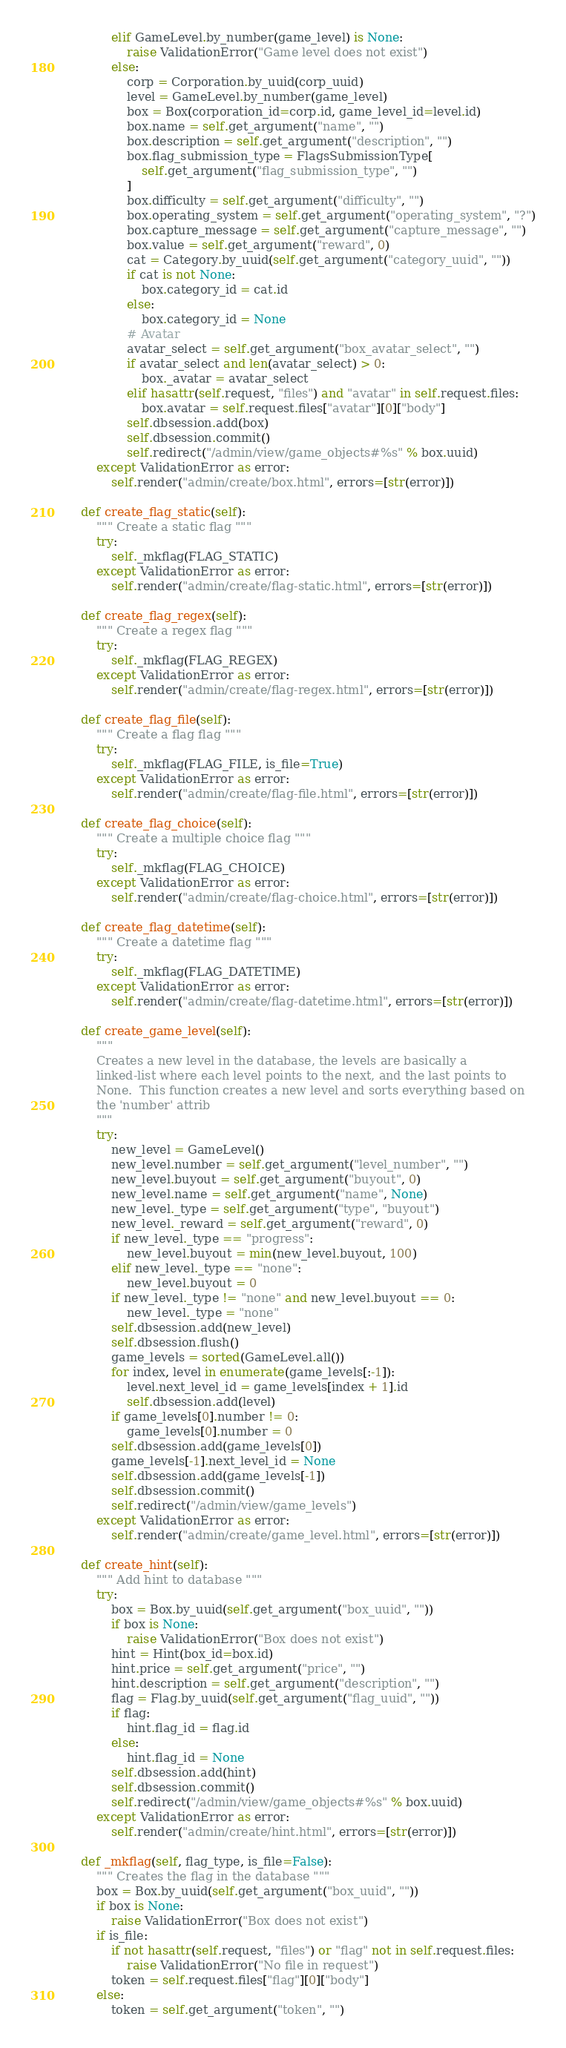Convert code to text. <code><loc_0><loc_0><loc_500><loc_500><_Python_>            elif GameLevel.by_number(game_level) is None:
                raise ValidationError("Game level does not exist")
            else:
                corp = Corporation.by_uuid(corp_uuid)
                level = GameLevel.by_number(game_level)
                box = Box(corporation_id=corp.id, game_level_id=level.id)
                box.name = self.get_argument("name", "")
                box.description = self.get_argument("description", "")
                box.flag_submission_type = FlagsSubmissionType[
                    self.get_argument("flag_submission_type", "")
                ]
                box.difficulty = self.get_argument("difficulty", "")
                box.operating_system = self.get_argument("operating_system", "?")
                box.capture_message = self.get_argument("capture_message", "")
                box.value = self.get_argument("reward", 0)
                cat = Category.by_uuid(self.get_argument("category_uuid", ""))
                if cat is not None:
                    box.category_id = cat.id
                else:
                    box.category_id = None
                # Avatar
                avatar_select = self.get_argument("box_avatar_select", "")
                if avatar_select and len(avatar_select) > 0:
                    box._avatar = avatar_select
                elif hasattr(self.request, "files") and "avatar" in self.request.files:
                    box.avatar = self.request.files["avatar"][0]["body"]
                self.dbsession.add(box)
                self.dbsession.commit()
                self.redirect("/admin/view/game_objects#%s" % box.uuid)
        except ValidationError as error:
            self.render("admin/create/box.html", errors=[str(error)])

    def create_flag_static(self):
        """ Create a static flag """
        try:
            self._mkflag(FLAG_STATIC)
        except ValidationError as error:
            self.render("admin/create/flag-static.html", errors=[str(error)])

    def create_flag_regex(self):
        """ Create a regex flag """
        try:
            self._mkflag(FLAG_REGEX)
        except ValidationError as error:
            self.render("admin/create/flag-regex.html", errors=[str(error)])

    def create_flag_file(self):
        """ Create a flag flag """
        try:
            self._mkflag(FLAG_FILE, is_file=True)
        except ValidationError as error:
            self.render("admin/create/flag-file.html", errors=[str(error)])

    def create_flag_choice(self):
        """ Create a multiple choice flag """
        try:
            self._mkflag(FLAG_CHOICE)
        except ValidationError as error:
            self.render("admin/create/flag-choice.html", errors=[str(error)])

    def create_flag_datetime(self):
        """ Create a datetime flag """
        try:
            self._mkflag(FLAG_DATETIME)
        except ValidationError as error:
            self.render("admin/create/flag-datetime.html", errors=[str(error)])

    def create_game_level(self):
        """
        Creates a new level in the database, the levels are basically a
        linked-list where each level points to the next, and the last points to
        None.  This function creates a new level and sorts everything based on
        the 'number' attrib
        """
        try:
            new_level = GameLevel()
            new_level.number = self.get_argument("level_number", "")
            new_level.buyout = self.get_argument("buyout", 0)
            new_level.name = self.get_argument("name", None)
            new_level._type = self.get_argument("type", "buyout")
            new_level._reward = self.get_argument("reward", 0)
            if new_level._type == "progress":
                new_level.buyout = min(new_level.buyout, 100)
            elif new_level._type == "none":
                new_level.buyout = 0
            if new_level._type != "none" and new_level.buyout == 0:
                new_level._type = "none"
            self.dbsession.add(new_level)
            self.dbsession.flush()
            game_levels = sorted(GameLevel.all())
            for index, level in enumerate(game_levels[:-1]):
                level.next_level_id = game_levels[index + 1].id
                self.dbsession.add(level)
            if game_levels[0].number != 0:
                game_levels[0].number = 0
            self.dbsession.add(game_levels[0])
            game_levels[-1].next_level_id = None
            self.dbsession.add(game_levels[-1])
            self.dbsession.commit()
            self.redirect("/admin/view/game_levels")
        except ValidationError as error:
            self.render("admin/create/game_level.html", errors=[str(error)])

    def create_hint(self):
        """ Add hint to database """
        try:
            box = Box.by_uuid(self.get_argument("box_uuid", ""))
            if box is None:
                raise ValidationError("Box does not exist")
            hint = Hint(box_id=box.id)
            hint.price = self.get_argument("price", "")
            hint.description = self.get_argument("description", "")
            flag = Flag.by_uuid(self.get_argument("flag_uuid", ""))
            if flag:
                hint.flag_id = flag.id
            else:
                hint.flag_id = None
            self.dbsession.add(hint)
            self.dbsession.commit()
            self.redirect("/admin/view/game_objects#%s" % box.uuid)
        except ValidationError as error:
            self.render("admin/create/hint.html", errors=[str(error)])

    def _mkflag(self, flag_type, is_file=False):
        """ Creates the flag in the database """
        box = Box.by_uuid(self.get_argument("box_uuid", ""))
        if box is None:
            raise ValidationError("Box does not exist")
        if is_file:
            if not hasattr(self.request, "files") or "flag" not in self.request.files:
                raise ValidationError("No file in request")
            token = self.request.files["flag"][0]["body"]
        else:
            token = self.get_argument("token", "")</code> 